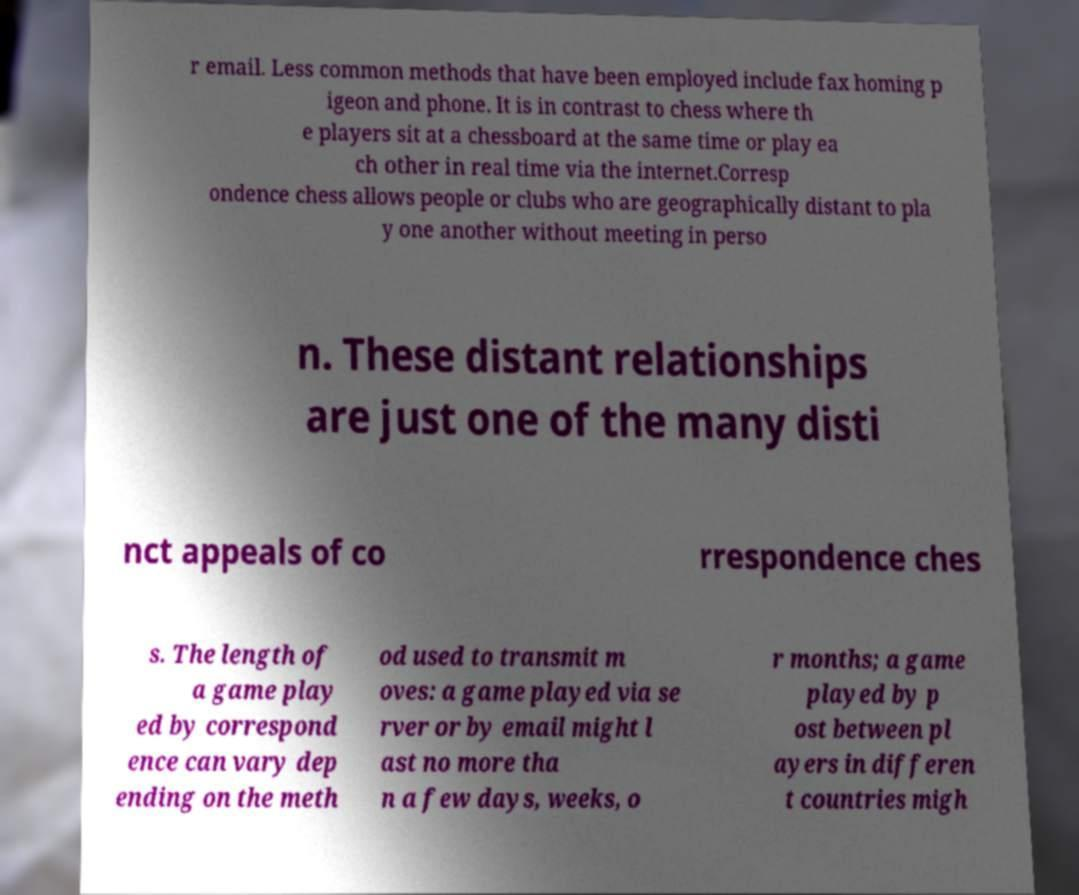Please read and relay the text visible in this image. What does it say? r email. Less common methods that have been employed include fax homing p igeon and phone. It is in contrast to chess where th e players sit at a chessboard at the same time or play ea ch other in real time via the internet.Corresp ondence chess allows people or clubs who are geographically distant to pla y one another without meeting in perso n. These distant relationships are just one of the many disti nct appeals of co rrespondence ches s. The length of a game play ed by correspond ence can vary dep ending on the meth od used to transmit m oves: a game played via se rver or by email might l ast no more tha n a few days, weeks, o r months; a game played by p ost between pl ayers in differen t countries migh 